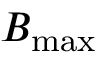<formula> <loc_0><loc_0><loc_500><loc_500>B _ { \max }</formula> 